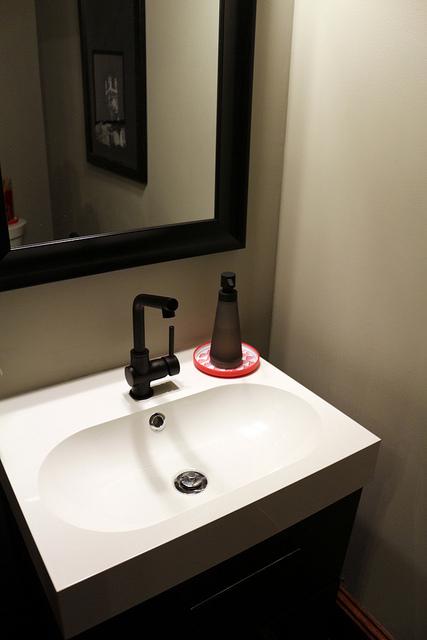Is there a hand towel hanging up on the rack for you to dry your hands?
Give a very brief answer. No. How many knobs are on the faucet?
Keep it brief. 1. What would you call the shiny object in the center of the bowl of the sink?
Answer briefly. Drain. 